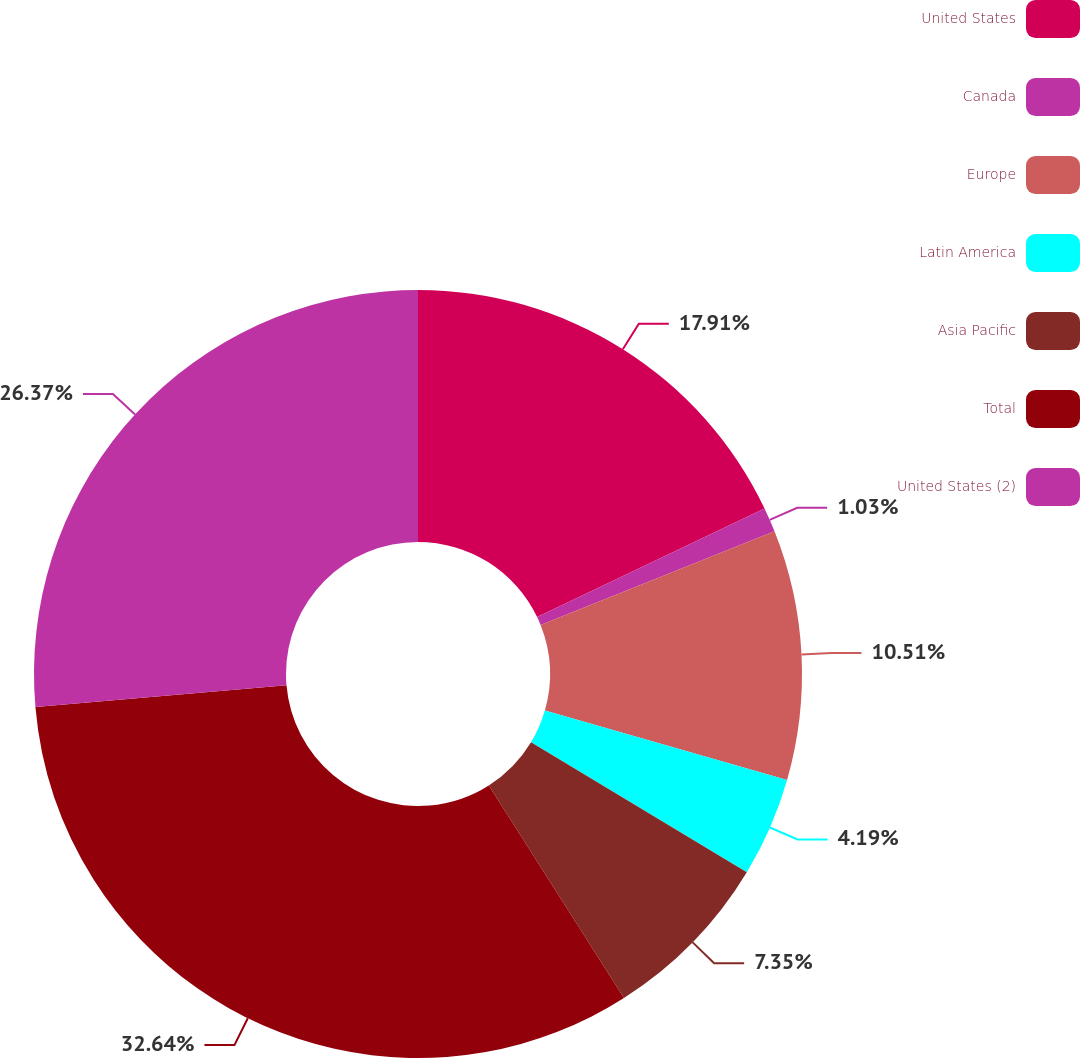Convert chart to OTSL. <chart><loc_0><loc_0><loc_500><loc_500><pie_chart><fcel>United States<fcel>Canada<fcel>Europe<fcel>Latin America<fcel>Asia Pacific<fcel>Total<fcel>United States (2)<nl><fcel>17.91%<fcel>1.03%<fcel>10.51%<fcel>4.19%<fcel>7.35%<fcel>32.64%<fcel>26.37%<nl></chart> 